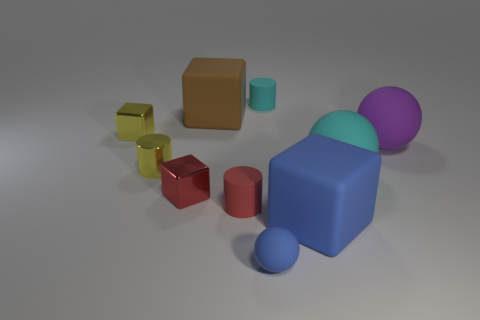Subtract all red matte cylinders. How many cylinders are left? 2 Subtract all spheres. How many objects are left? 7 Subtract all blue spheres. How many spheres are left? 2 Subtract 3 cubes. How many cubes are left? 1 Subtract all big objects. Subtract all tiny things. How many objects are left? 0 Add 3 red shiny things. How many red shiny things are left? 4 Add 2 large cyan balls. How many large cyan balls exist? 3 Subtract 0 purple cylinders. How many objects are left? 10 Subtract all gray blocks. Subtract all blue cylinders. How many blocks are left? 4 Subtract all red cylinders. How many purple balls are left? 1 